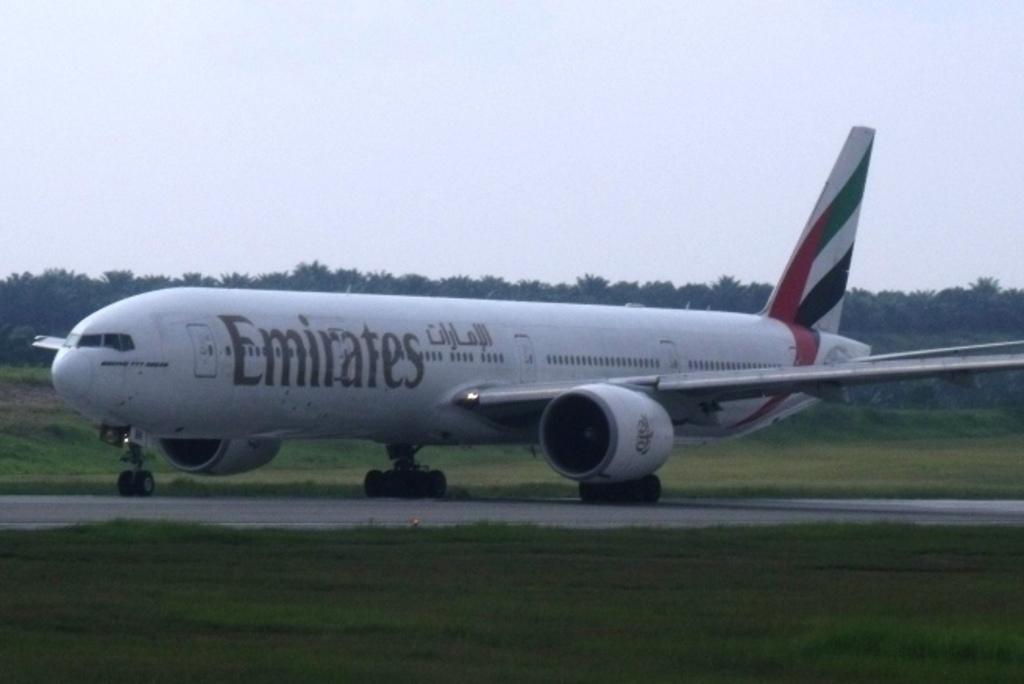Please provide a concise description of this image. In this picture we can see an airplane on the runway, in the background we can see grass and few trees. 